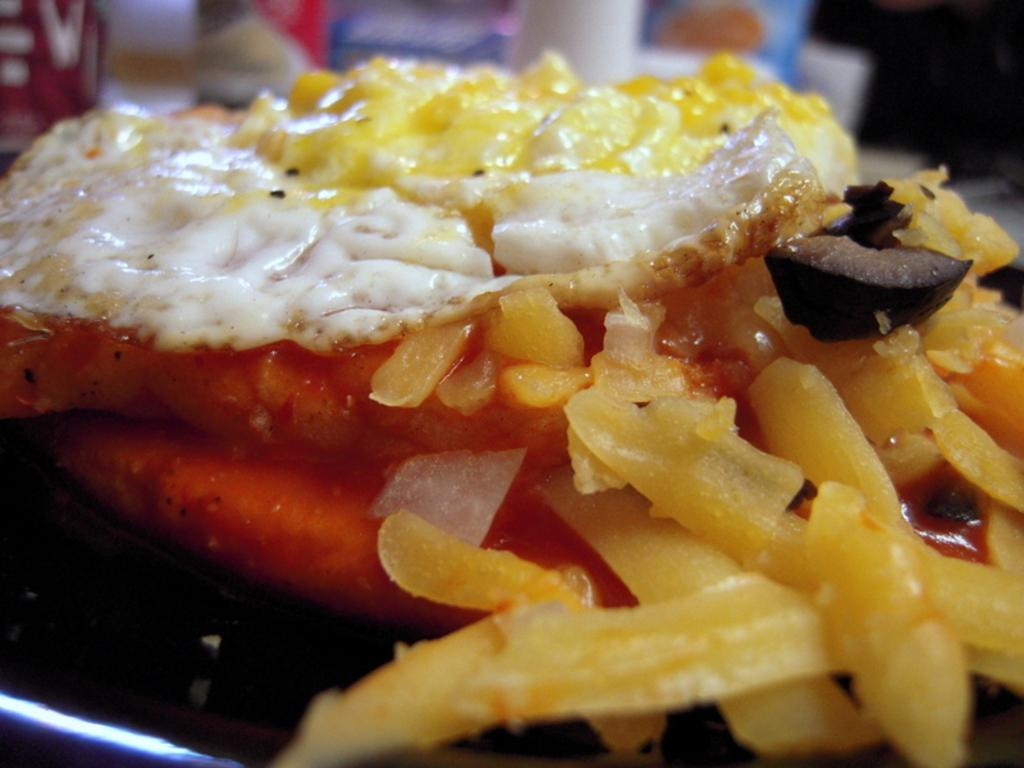What is present in the image? There is food in the image. Can you see a crow attempting to use an appliance in the image? There is no crow or appliance present in the image. 